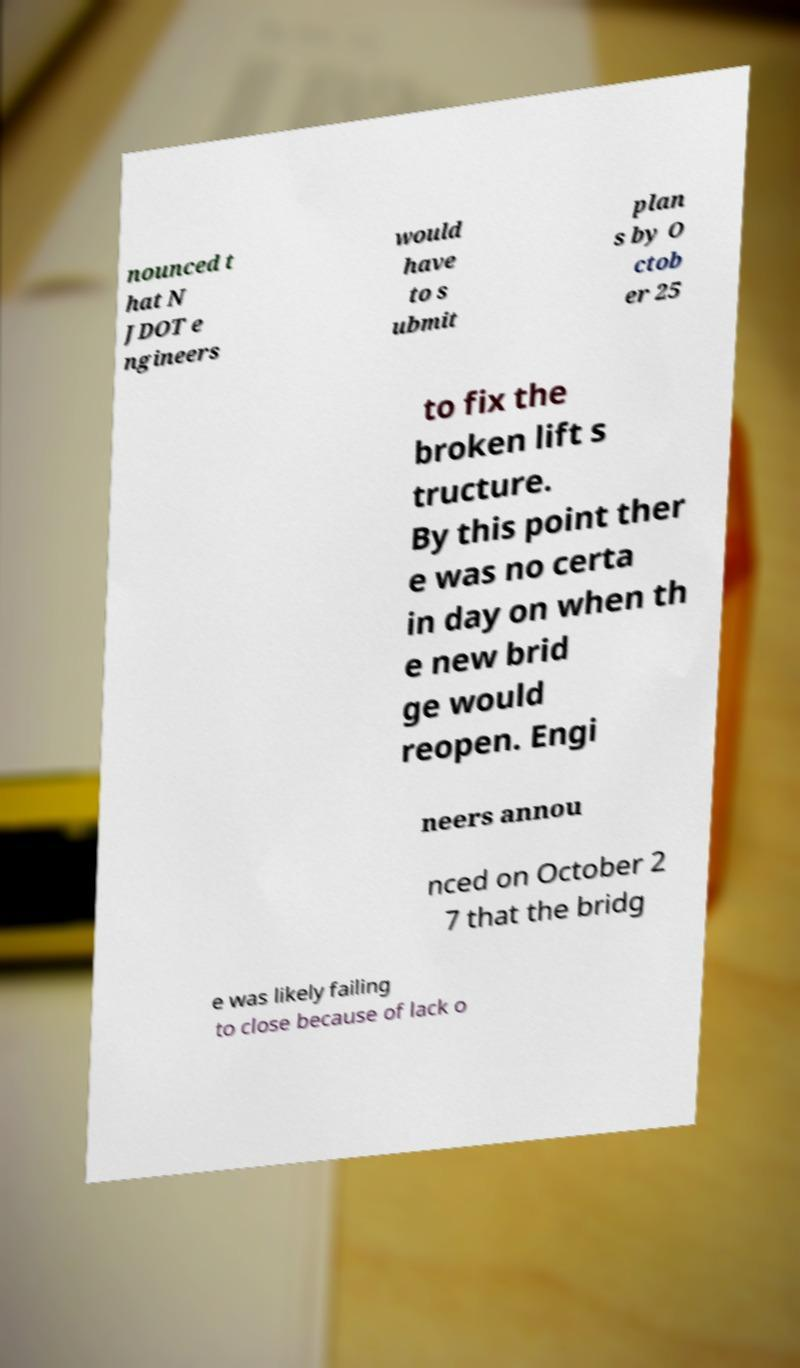Can you read and provide the text displayed in the image?This photo seems to have some interesting text. Can you extract and type it out for me? nounced t hat N JDOT e ngineers would have to s ubmit plan s by O ctob er 25 to fix the broken lift s tructure. By this point ther e was no certa in day on when th e new brid ge would reopen. Engi neers annou nced on October 2 7 that the bridg e was likely failing to close because of lack o 